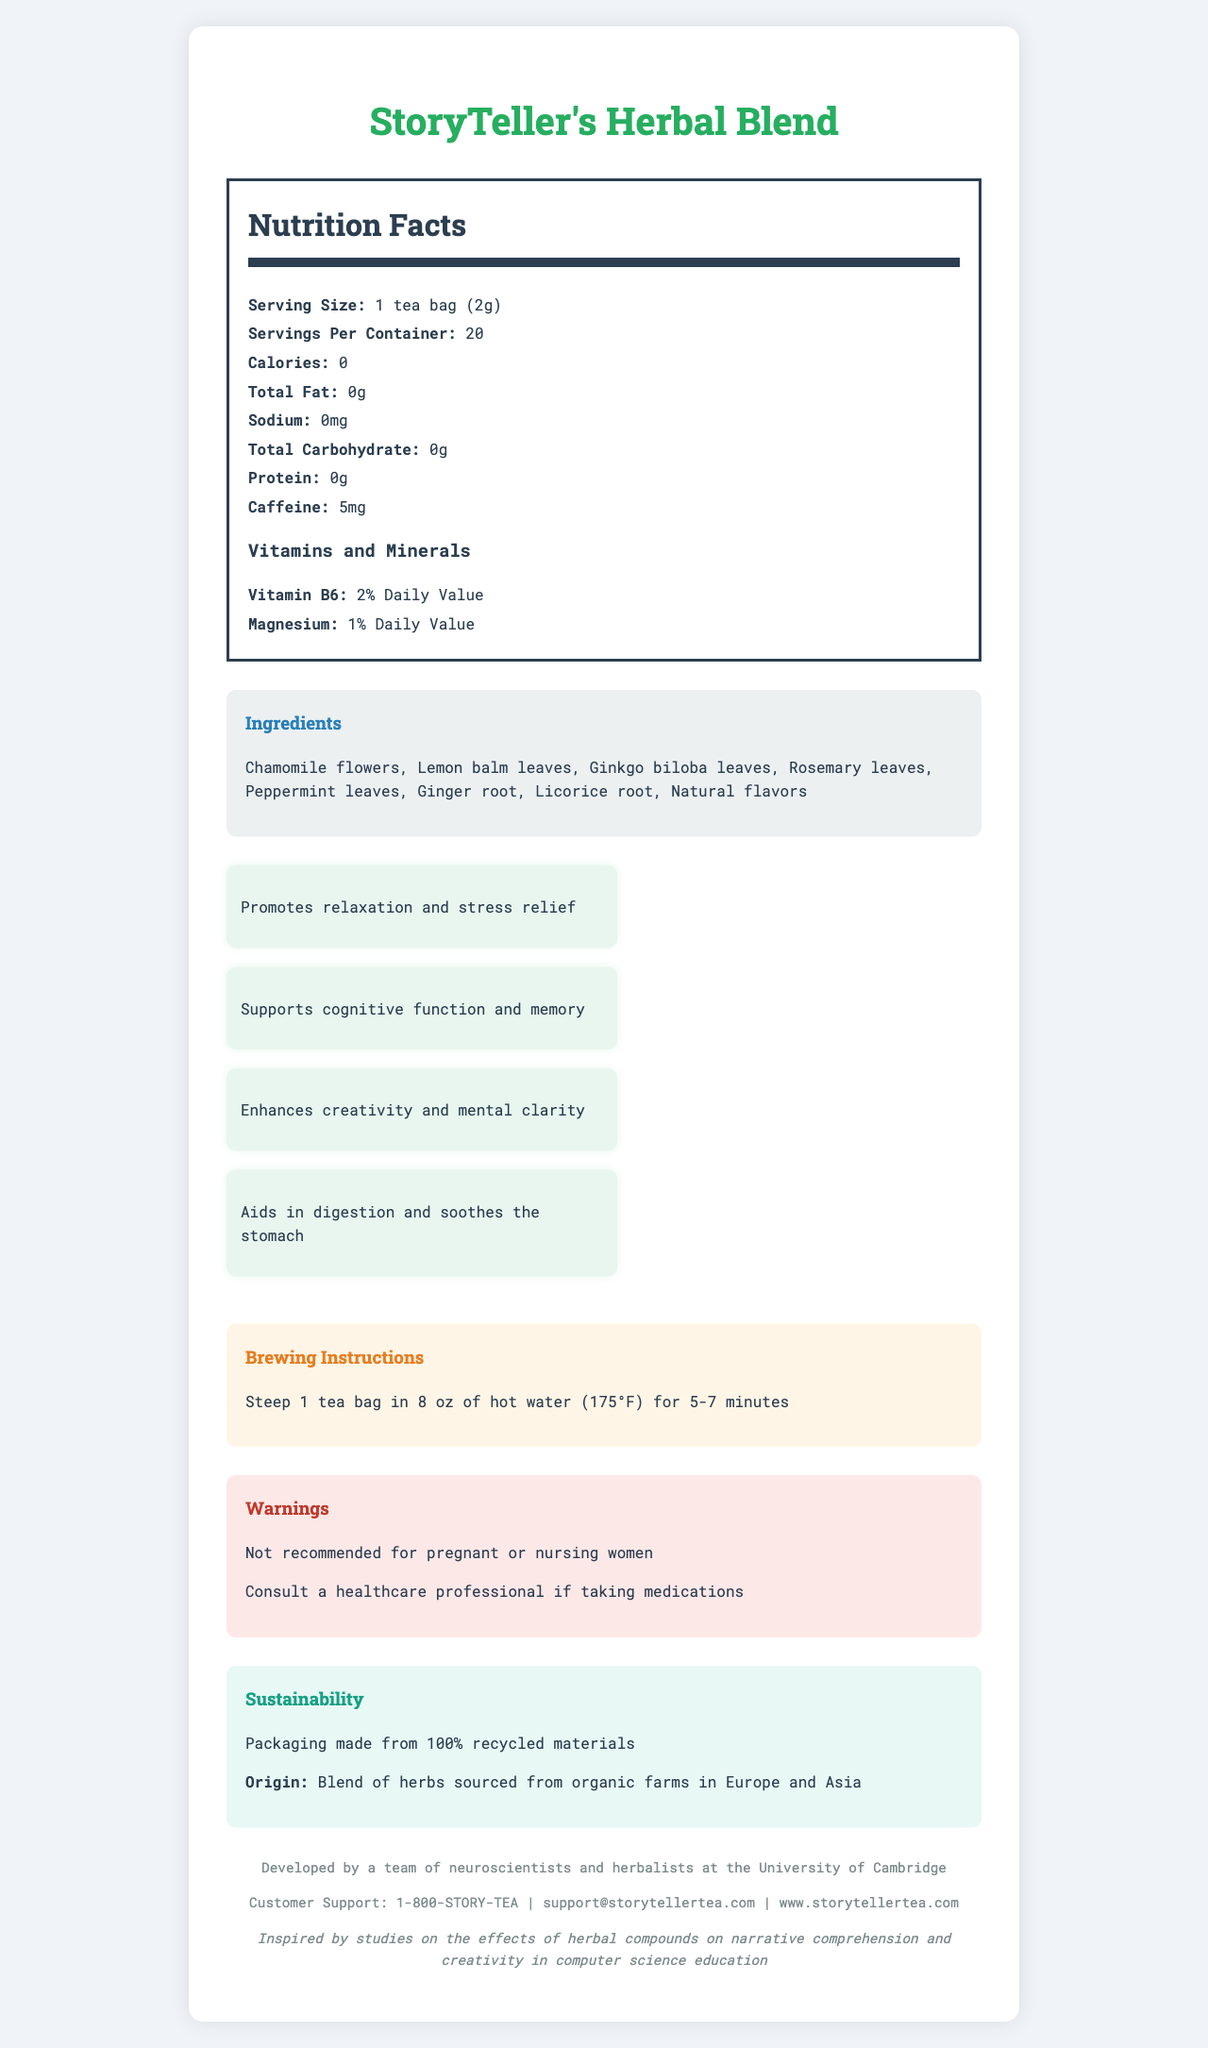what is the serving size? The serving size is stated directly in the Nutrition Facts section: "Serving Size: 1 tea bag (2g)".
Answer: 1 tea bag (2g) how many servings are there per container? The number of servings per container is listed as "Servings Per Container: 20" in the Nutrition Facts section.
Answer: 20 how many calories are in one serving of the tea? The Nutrition Facts section indicates that there are 0 calories per serving: "Calories: 0".
Answer: 0 list three ingredients in the blend. The ingredients are listed under the Ingredients section: "Chamomile flowers, Lemon balm leaves, Ginkgo biloba leaves, Rosemary leaves, Peppermint leaves, Ginger root, Licorice root, Natural flavors".
Answer: Chamomile flowers, Lemon balm leaves, Ginkgo biloba leaves what is the caffeine content per serving? The Nutrition Facts section lists the caffeine content as 5mg: "Caffeine: 5mg".
Answer: 5mg which of the following is not an ingredient in the tea? A. Ginger root B. Green tea leaves C. Licorice root D. Lemon balm leaves Green tea leaves is not listed as an ingredient. The listed ingredients include Ginger root, Licorice root, and Lemon balm leaves.
Answer: B how much Vitamin B6 does one serving provide? A. 0% Daily Value B. 1% Daily Value C. 2% Daily Value D. 5% Daily Value The Vitamins and Minerals section lists Vitamin B6 as providing 2% of the Daily Value: "Vitamin B6: 2% Daily Value".
Answer: C are there any warnings associated with the use of this tea? There are warnings listed under the Warnings section: "Not recommended for pregnant or nursing women", "Consult a healthcare professional if taking medications".
Answer: Yes describe the main benefits of consuming this tea. The Health Benefits section lists the main benefits as: "Promotes relaxation and stress relief", "Supports cognitive function and memory", "Enhances creativity and mental clarity", and "Aids in digestion and soothes the stomach".
Answer: Promotes relaxation, supports cognitive function, enhances creativity, aids digestion what is the brewing temperature and duration for this tea? The Brewing Instructions section states: "Steep 1 tea bag in 8 oz of hot water (175°F) for 5-7 minutes".
Answer: 175°F for 5-7 minutes is the packaging material sustainable? The document mentions in the Sustainability section: "Packaging made from 100% recycled materials".
Answer: Yes who developed this tea blend? The document mentions the company story: "Developed by a team of neuroscientists and herbalists at the University of Cambridge".
Answer: A team of neuroscientists and herbalists at the University of Cambridge what is the customer support phone number? The Customer Support section lists the phone number as: "Customer Support: 1-800-STORY-TEA".
Answer: 1-800-STORY-TEA what are the origins of the herbs used in this blend? The Sustainability section mentions: "Blend of herbs sourced from organic farms in Europe and Asia".
Answer: Europe and Asia is this tea blend suitable for pregnant women? The Warnings section states: "Not recommended for pregnant or nursing women".
Answer: No what is the total fat content per serving? The Nutrition Facts section states: "Total Fat: 0g".
Answer: 0g summarize the entire document focusing on its key details. This summary encapsulates the key points including the nutritional facts, ingredients, health benefits, brewing instructions, warnings, sustainability, origin of ingredients, and development team.
Answer: The document outlines the "StoryTeller's Herbal Blend" tea, highlighting its zero-calories, low-caffeine content of 5mg per serving, and its beneficial ingredients like chamomile and ginkgo biloba. The tea promotes relaxation, supports cognitive function, enhances creativity, and aids digestion. Brewing instructions suggest steeping at 175°F for 5-7 minutes. Warnings note it isn't recommended for pregnant women. The blend's sustainable packaging is from recycled materials, and the herbs are organically sourced from Europe and Asia. It was developed by a unique team at the University of Cambridge. Customer support contact details are provided. how many grams of protein are in one serving? The Nutrition Facts section indicates: "Protein: 0g".
Answer: 0g can consuming this tea aid in digestion? One of the health benefits listed is: "Aids in digestion and soothes the stomach".
Answer: Yes does this tea provide any magnesium? The Vitamins and Minerals section lists: "Magnesium: 1% Daily Value".
Answer: Yes what is the goal of the research related to this tea? The document does not provide specific details about the goal of the research, just that it was "inspired by studies on the effects of herbal compounds on narrative comprehension and creativity in computer science education".
Answer: Not enough information 